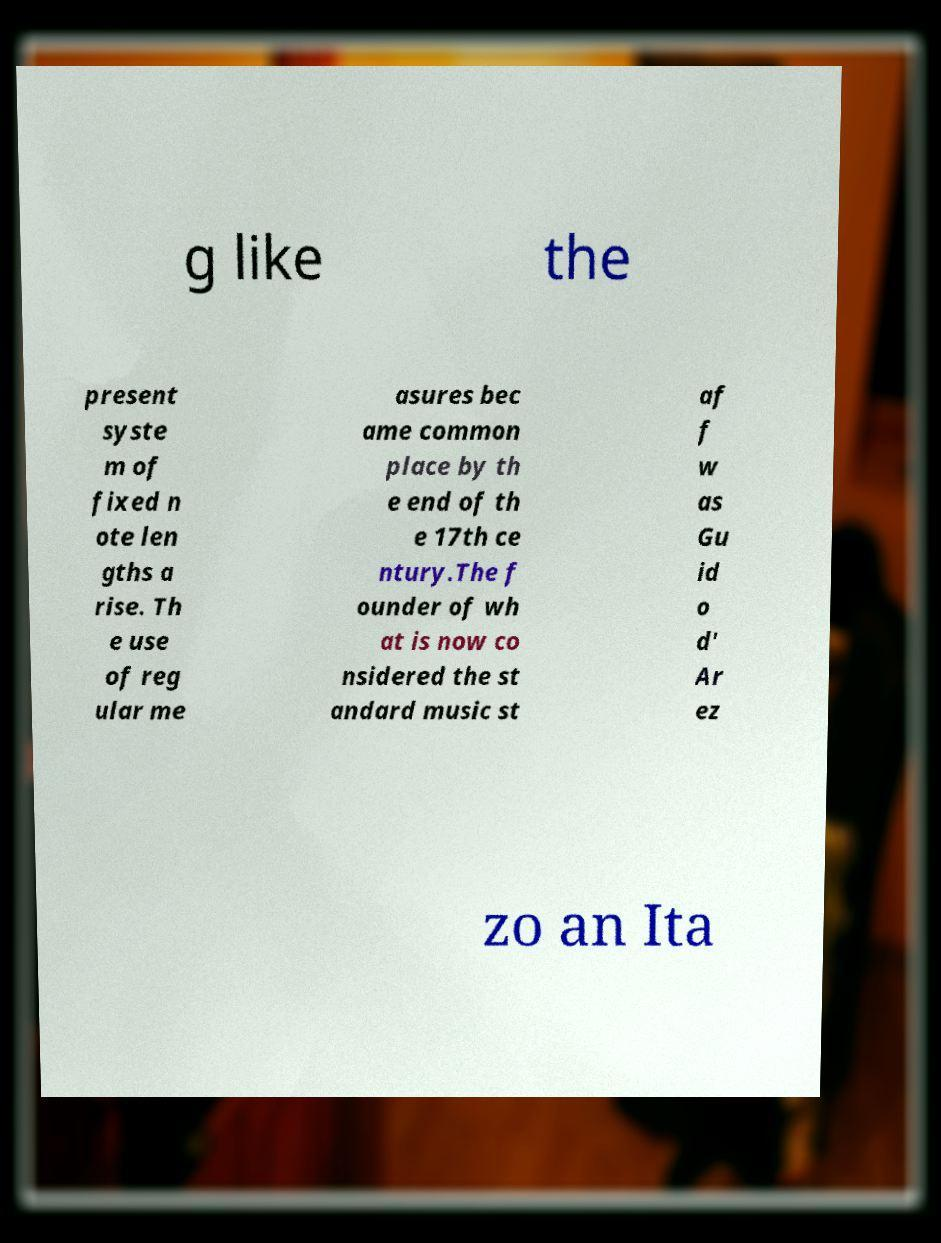Please read and relay the text visible in this image. What does it say? g like the present syste m of fixed n ote len gths a rise. Th e use of reg ular me asures bec ame common place by th e end of th e 17th ce ntury.The f ounder of wh at is now co nsidered the st andard music st af f w as Gu id o d' Ar ez zo an Ita 